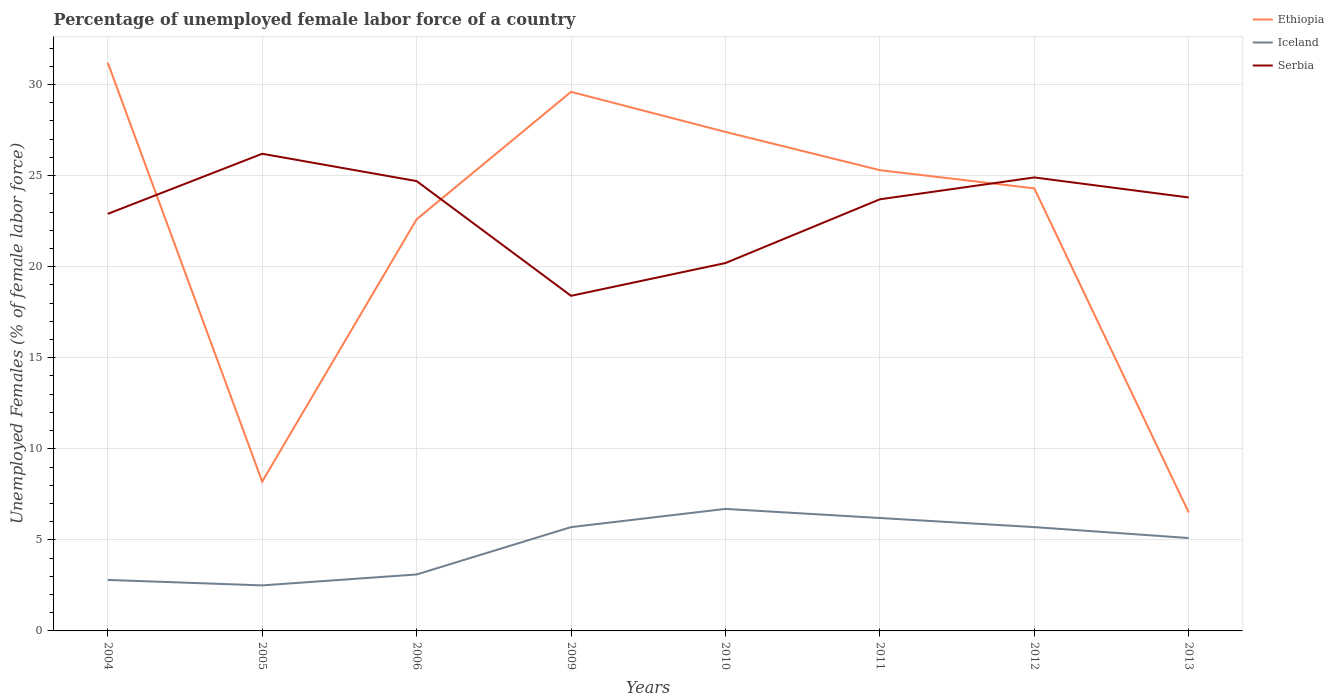Is the number of lines equal to the number of legend labels?
Provide a succinct answer. Yes. What is the total percentage of unemployed female labor force in Serbia in the graph?
Give a very brief answer. 6.3. What is the difference between the highest and the second highest percentage of unemployed female labor force in Iceland?
Provide a succinct answer. 4.2. What is the difference between the highest and the lowest percentage of unemployed female labor force in Iceland?
Your answer should be very brief. 5. Is the percentage of unemployed female labor force in Iceland strictly greater than the percentage of unemployed female labor force in Ethiopia over the years?
Make the answer very short. Yes. How many lines are there?
Your response must be concise. 3. How many years are there in the graph?
Provide a short and direct response. 8. Are the values on the major ticks of Y-axis written in scientific E-notation?
Keep it short and to the point. No. Does the graph contain grids?
Provide a succinct answer. Yes. Where does the legend appear in the graph?
Your response must be concise. Top right. How many legend labels are there?
Your answer should be compact. 3. How are the legend labels stacked?
Make the answer very short. Vertical. What is the title of the graph?
Your answer should be compact. Percentage of unemployed female labor force of a country. Does "American Samoa" appear as one of the legend labels in the graph?
Your answer should be very brief. No. What is the label or title of the Y-axis?
Keep it short and to the point. Unemployed Females (% of female labor force). What is the Unemployed Females (% of female labor force) of Ethiopia in 2004?
Make the answer very short. 31.2. What is the Unemployed Females (% of female labor force) in Iceland in 2004?
Give a very brief answer. 2.8. What is the Unemployed Females (% of female labor force) of Serbia in 2004?
Provide a succinct answer. 22.9. What is the Unemployed Females (% of female labor force) of Ethiopia in 2005?
Give a very brief answer. 8.2. What is the Unemployed Females (% of female labor force) of Serbia in 2005?
Make the answer very short. 26.2. What is the Unemployed Females (% of female labor force) of Ethiopia in 2006?
Provide a short and direct response. 22.6. What is the Unemployed Females (% of female labor force) of Iceland in 2006?
Offer a terse response. 3.1. What is the Unemployed Females (% of female labor force) in Serbia in 2006?
Ensure brevity in your answer.  24.7. What is the Unemployed Females (% of female labor force) of Ethiopia in 2009?
Provide a succinct answer. 29.6. What is the Unemployed Females (% of female labor force) of Iceland in 2009?
Provide a short and direct response. 5.7. What is the Unemployed Females (% of female labor force) of Serbia in 2009?
Offer a very short reply. 18.4. What is the Unemployed Females (% of female labor force) in Ethiopia in 2010?
Ensure brevity in your answer.  27.4. What is the Unemployed Females (% of female labor force) of Iceland in 2010?
Make the answer very short. 6.7. What is the Unemployed Females (% of female labor force) of Serbia in 2010?
Provide a short and direct response. 20.2. What is the Unemployed Females (% of female labor force) in Ethiopia in 2011?
Make the answer very short. 25.3. What is the Unemployed Females (% of female labor force) in Iceland in 2011?
Your response must be concise. 6.2. What is the Unemployed Females (% of female labor force) of Serbia in 2011?
Offer a terse response. 23.7. What is the Unemployed Females (% of female labor force) of Ethiopia in 2012?
Keep it short and to the point. 24.3. What is the Unemployed Females (% of female labor force) in Iceland in 2012?
Provide a short and direct response. 5.7. What is the Unemployed Females (% of female labor force) in Serbia in 2012?
Ensure brevity in your answer.  24.9. What is the Unemployed Females (% of female labor force) in Ethiopia in 2013?
Provide a short and direct response. 6.5. What is the Unemployed Females (% of female labor force) in Iceland in 2013?
Provide a short and direct response. 5.1. What is the Unemployed Females (% of female labor force) of Serbia in 2013?
Make the answer very short. 23.8. Across all years, what is the maximum Unemployed Females (% of female labor force) in Ethiopia?
Keep it short and to the point. 31.2. Across all years, what is the maximum Unemployed Females (% of female labor force) of Iceland?
Give a very brief answer. 6.7. Across all years, what is the maximum Unemployed Females (% of female labor force) of Serbia?
Provide a succinct answer. 26.2. Across all years, what is the minimum Unemployed Females (% of female labor force) of Ethiopia?
Provide a short and direct response. 6.5. Across all years, what is the minimum Unemployed Females (% of female labor force) in Iceland?
Your response must be concise. 2.5. Across all years, what is the minimum Unemployed Females (% of female labor force) in Serbia?
Offer a terse response. 18.4. What is the total Unemployed Females (% of female labor force) in Ethiopia in the graph?
Your answer should be very brief. 175.1. What is the total Unemployed Females (% of female labor force) in Iceland in the graph?
Your answer should be compact. 37.8. What is the total Unemployed Females (% of female labor force) of Serbia in the graph?
Keep it short and to the point. 184.8. What is the difference between the Unemployed Females (% of female labor force) of Ethiopia in 2004 and that in 2005?
Your answer should be very brief. 23. What is the difference between the Unemployed Females (% of female labor force) of Iceland in 2004 and that in 2005?
Your response must be concise. 0.3. What is the difference between the Unemployed Females (% of female labor force) of Serbia in 2004 and that in 2005?
Your answer should be compact. -3.3. What is the difference between the Unemployed Females (% of female labor force) in Ethiopia in 2004 and that in 2006?
Provide a short and direct response. 8.6. What is the difference between the Unemployed Females (% of female labor force) in Iceland in 2004 and that in 2009?
Your response must be concise. -2.9. What is the difference between the Unemployed Females (% of female labor force) of Serbia in 2004 and that in 2010?
Your answer should be compact. 2.7. What is the difference between the Unemployed Females (% of female labor force) of Iceland in 2004 and that in 2011?
Provide a succinct answer. -3.4. What is the difference between the Unemployed Females (% of female labor force) in Ethiopia in 2004 and that in 2012?
Make the answer very short. 6.9. What is the difference between the Unemployed Females (% of female labor force) of Iceland in 2004 and that in 2012?
Ensure brevity in your answer.  -2.9. What is the difference between the Unemployed Females (% of female labor force) of Ethiopia in 2004 and that in 2013?
Provide a succinct answer. 24.7. What is the difference between the Unemployed Females (% of female labor force) in Iceland in 2004 and that in 2013?
Your response must be concise. -2.3. What is the difference between the Unemployed Females (% of female labor force) in Serbia in 2004 and that in 2013?
Keep it short and to the point. -0.9. What is the difference between the Unemployed Females (% of female labor force) of Ethiopia in 2005 and that in 2006?
Keep it short and to the point. -14.4. What is the difference between the Unemployed Females (% of female labor force) in Serbia in 2005 and that in 2006?
Offer a very short reply. 1.5. What is the difference between the Unemployed Females (% of female labor force) in Ethiopia in 2005 and that in 2009?
Your answer should be very brief. -21.4. What is the difference between the Unemployed Females (% of female labor force) in Ethiopia in 2005 and that in 2010?
Your response must be concise. -19.2. What is the difference between the Unemployed Females (% of female labor force) in Iceland in 2005 and that in 2010?
Provide a succinct answer. -4.2. What is the difference between the Unemployed Females (% of female labor force) of Ethiopia in 2005 and that in 2011?
Keep it short and to the point. -17.1. What is the difference between the Unemployed Females (% of female labor force) of Serbia in 2005 and that in 2011?
Provide a short and direct response. 2.5. What is the difference between the Unemployed Females (% of female labor force) in Ethiopia in 2005 and that in 2012?
Offer a terse response. -16.1. What is the difference between the Unemployed Females (% of female labor force) in Iceland in 2005 and that in 2012?
Offer a very short reply. -3.2. What is the difference between the Unemployed Females (% of female labor force) in Ethiopia in 2005 and that in 2013?
Offer a very short reply. 1.7. What is the difference between the Unemployed Females (% of female labor force) in Iceland in 2005 and that in 2013?
Offer a terse response. -2.6. What is the difference between the Unemployed Females (% of female labor force) of Iceland in 2006 and that in 2009?
Provide a succinct answer. -2.6. What is the difference between the Unemployed Females (% of female labor force) of Serbia in 2006 and that in 2010?
Give a very brief answer. 4.5. What is the difference between the Unemployed Females (% of female labor force) of Serbia in 2006 and that in 2011?
Give a very brief answer. 1. What is the difference between the Unemployed Females (% of female labor force) of Ethiopia in 2006 and that in 2012?
Give a very brief answer. -1.7. What is the difference between the Unemployed Females (% of female labor force) in Iceland in 2006 and that in 2012?
Make the answer very short. -2.6. What is the difference between the Unemployed Females (% of female labor force) in Serbia in 2006 and that in 2012?
Keep it short and to the point. -0.2. What is the difference between the Unemployed Females (% of female labor force) in Ethiopia in 2006 and that in 2013?
Offer a terse response. 16.1. What is the difference between the Unemployed Females (% of female labor force) of Iceland in 2006 and that in 2013?
Offer a terse response. -2. What is the difference between the Unemployed Females (% of female labor force) in Serbia in 2006 and that in 2013?
Your response must be concise. 0.9. What is the difference between the Unemployed Females (% of female labor force) in Ethiopia in 2009 and that in 2010?
Your answer should be very brief. 2.2. What is the difference between the Unemployed Females (% of female labor force) of Iceland in 2009 and that in 2010?
Your answer should be very brief. -1. What is the difference between the Unemployed Females (% of female labor force) in Iceland in 2009 and that in 2012?
Provide a succinct answer. 0. What is the difference between the Unemployed Females (% of female labor force) of Serbia in 2009 and that in 2012?
Give a very brief answer. -6.5. What is the difference between the Unemployed Females (% of female labor force) in Ethiopia in 2009 and that in 2013?
Ensure brevity in your answer.  23.1. What is the difference between the Unemployed Females (% of female labor force) in Iceland in 2009 and that in 2013?
Offer a terse response. 0.6. What is the difference between the Unemployed Females (% of female labor force) in Serbia in 2009 and that in 2013?
Your answer should be very brief. -5.4. What is the difference between the Unemployed Females (% of female labor force) in Iceland in 2010 and that in 2011?
Provide a succinct answer. 0.5. What is the difference between the Unemployed Females (% of female labor force) of Serbia in 2010 and that in 2011?
Provide a succinct answer. -3.5. What is the difference between the Unemployed Females (% of female labor force) of Serbia in 2010 and that in 2012?
Your answer should be compact. -4.7. What is the difference between the Unemployed Females (% of female labor force) of Ethiopia in 2010 and that in 2013?
Provide a short and direct response. 20.9. What is the difference between the Unemployed Females (% of female labor force) of Serbia in 2010 and that in 2013?
Make the answer very short. -3.6. What is the difference between the Unemployed Females (% of female labor force) in Ethiopia in 2011 and that in 2012?
Keep it short and to the point. 1. What is the difference between the Unemployed Females (% of female labor force) in Iceland in 2011 and that in 2012?
Provide a short and direct response. 0.5. What is the difference between the Unemployed Females (% of female labor force) of Serbia in 2011 and that in 2012?
Your answer should be very brief. -1.2. What is the difference between the Unemployed Females (% of female labor force) in Ethiopia in 2011 and that in 2013?
Offer a very short reply. 18.8. What is the difference between the Unemployed Females (% of female labor force) in Serbia in 2011 and that in 2013?
Offer a very short reply. -0.1. What is the difference between the Unemployed Females (% of female labor force) of Ethiopia in 2012 and that in 2013?
Offer a terse response. 17.8. What is the difference between the Unemployed Females (% of female labor force) in Ethiopia in 2004 and the Unemployed Females (% of female labor force) in Iceland in 2005?
Your answer should be very brief. 28.7. What is the difference between the Unemployed Females (% of female labor force) of Iceland in 2004 and the Unemployed Females (% of female labor force) of Serbia in 2005?
Offer a terse response. -23.4. What is the difference between the Unemployed Females (% of female labor force) of Ethiopia in 2004 and the Unemployed Females (% of female labor force) of Iceland in 2006?
Your answer should be compact. 28.1. What is the difference between the Unemployed Females (% of female labor force) of Iceland in 2004 and the Unemployed Females (% of female labor force) of Serbia in 2006?
Make the answer very short. -21.9. What is the difference between the Unemployed Females (% of female labor force) of Ethiopia in 2004 and the Unemployed Females (% of female labor force) of Iceland in 2009?
Offer a terse response. 25.5. What is the difference between the Unemployed Females (% of female labor force) of Iceland in 2004 and the Unemployed Females (% of female labor force) of Serbia in 2009?
Offer a very short reply. -15.6. What is the difference between the Unemployed Females (% of female labor force) of Ethiopia in 2004 and the Unemployed Females (% of female labor force) of Iceland in 2010?
Provide a short and direct response. 24.5. What is the difference between the Unemployed Females (% of female labor force) of Iceland in 2004 and the Unemployed Females (% of female labor force) of Serbia in 2010?
Provide a short and direct response. -17.4. What is the difference between the Unemployed Females (% of female labor force) in Iceland in 2004 and the Unemployed Females (% of female labor force) in Serbia in 2011?
Offer a terse response. -20.9. What is the difference between the Unemployed Females (% of female labor force) of Ethiopia in 2004 and the Unemployed Females (% of female labor force) of Serbia in 2012?
Ensure brevity in your answer.  6.3. What is the difference between the Unemployed Females (% of female labor force) in Iceland in 2004 and the Unemployed Females (% of female labor force) in Serbia in 2012?
Your response must be concise. -22.1. What is the difference between the Unemployed Females (% of female labor force) of Ethiopia in 2004 and the Unemployed Females (% of female labor force) of Iceland in 2013?
Provide a short and direct response. 26.1. What is the difference between the Unemployed Females (% of female labor force) of Ethiopia in 2004 and the Unemployed Females (% of female labor force) of Serbia in 2013?
Offer a very short reply. 7.4. What is the difference between the Unemployed Females (% of female labor force) of Ethiopia in 2005 and the Unemployed Females (% of female labor force) of Serbia in 2006?
Give a very brief answer. -16.5. What is the difference between the Unemployed Females (% of female labor force) of Iceland in 2005 and the Unemployed Females (% of female labor force) of Serbia in 2006?
Provide a succinct answer. -22.2. What is the difference between the Unemployed Females (% of female labor force) in Ethiopia in 2005 and the Unemployed Females (% of female labor force) in Serbia in 2009?
Your answer should be very brief. -10.2. What is the difference between the Unemployed Females (% of female labor force) of Iceland in 2005 and the Unemployed Females (% of female labor force) of Serbia in 2009?
Provide a short and direct response. -15.9. What is the difference between the Unemployed Females (% of female labor force) in Ethiopia in 2005 and the Unemployed Females (% of female labor force) in Iceland in 2010?
Give a very brief answer. 1.5. What is the difference between the Unemployed Females (% of female labor force) in Ethiopia in 2005 and the Unemployed Females (% of female labor force) in Serbia in 2010?
Provide a short and direct response. -12. What is the difference between the Unemployed Females (% of female labor force) in Iceland in 2005 and the Unemployed Females (% of female labor force) in Serbia in 2010?
Keep it short and to the point. -17.7. What is the difference between the Unemployed Females (% of female labor force) in Ethiopia in 2005 and the Unemployed Females (% of female labor force) in Iceland in 2011?
Offer a terse response. 2. What is the difference between the Unemployed Females (% of female labor force) of Ethiopia in 2005 and the Unemployed Females (% of female labor force) of Serbia in 2011?
Provide a succinct answer. -15.5. What is the difference between the Unemployed Females (% of female labor force) in Iceland in 2005 and the Unemployed Females (% of female labor force) in Serbia in 2011?
Make the answer very short. -21.2. What is the difference between the Unemployed Females (% of female labor force) of Ethiopia in 2005 and the Unemployed Females (% of female labor force) of Iceland in 2012?
Give a very brief answer. 2.5. What is the difference between the Unemployed Females (% of female labor force) in Ethiopia in 2005 and the Unemployed Females (% of female labor force) in Serbia in 2012?
Your response must be concise. -16.7. What is the difference between the Unemployed Females (% of female labor force) of Iceland in 2005 and the Unemployed Females (% of female labor force) of Serbia in 2012?
Offer a very short reply. -22.4. What is the difference between the Unemployed Females (% of female labor force) in Ethiopia in 2005 and the Unemployed Females (% of female labor force) in Serbia in 2013?
Provide a short and direct response. -15.6. What is the difference between the Unemployed Females (% of female labor force) in Iceland in 2005 and the Unemployed Females (% of female labor force) in Serbia in 2013?
Provide a succinct answer. -21.3. What is the difference between the Unemployed Females (% of female labor force) of Ethiopia in 2006 and the Unemployed Females (% of female labor force) of Serbia in 2009?
Your answer should be very brief. 4.2. What is the difference between the Unemployed Females (% of female labor force) of Iceland in 2006 and the Unemployed Females (% of female labor force) of Serbia in 2009?
Keep it short and to the point. -15.3. What is the difference between the Unemployed Females (% of female labor force) in Iceland in 2006 and the Unemployed Females (% of female labor force) in Serbia in 2010?
Offer a terse response. -17.1. What is the difference between the Unemployed Females (% of female labor force) in Ethiopia in 2006 and the Unemployed Females (% of female labor force) in Iceland in 2011?
Offer a terse response. 16.4. What is the difference between the Unemployed Females (% of female labor force) of Iceland in 2006 and the Unemployed Females (% of female labor force) of Serbia in 2011?
Make the answer very short. -20.6. What is the difference between the Unemployed Females (% of female labor force) in Iceland in 2006 and the Unemployed Females (% of female labor force) in Serbia in 2012?
Ensure brevity in your answer.  -21.8. What is the difference between the Unemployed Females (% of female labor force) of Ethiopia in 2006 and the Unemployed Females (% of female labor force) of Serbia in 2013?
Provide a short and direct response. -1.2. What is the difference between the Unemployed Females (% of female labor force) of Iceland in 2006 and the Unemployed Females (% of female labor force) of Serbia in 2013?
Provide a short and direct response. -20.7. What is the difference between the Unemployed Females (% of female labor force) of Ethiopia in 2009 and the Unemployed Females (% of female labor force) of Iceland in 2010?
Keep it short and to the point. 22.9. What is the difference between the Unemployed Females (% of female labor force) of Ethiopia in 2009 and the Unemployed Females (% of female labor force) of Iceland in 2011?
Provide a short and direct response. 23.4. What is the difference between the Unemployed Females (% of female labor force) of Iceland in 2009 and the Unemployed Females (% of female labor force) of Serbia in 2011?
Offer a terse response. -18. What is the difference between the Unemployed Females (% of female labor force) of Ethiopia in 2009 and the Unemployed Females (% of female labor force) of Iceland in 2012?
Provide a succinct answer. 23.9. What is the difference between the Unemployed Females (% of female labor force) of Ethiopia in 2009 and the Unemployed Females (% of female labor force) of Serbia in 2012?
Give a very brief answer. 4.7. What is the difference between the Unemployed Females (% of female labor force) in Iceland in 2009 and the Unemployed Females (% of female labor force) in Serbia in 2012?
Your answer should be compact. -19.2. What is the difference between the Unemployed Females (% of female labor force) of Ethiopia in 2009 and the Unemployed Females (% of female labor force) of Iceland in 2013?
Offer a very short reply. 24.5. What is the difference between the Unemployed Females (% of female labor force) of Ethiopia in 2009 and the Unemployed Females (% of female labor force) of Serbia in 2013?
Give a very brief answer. 5.8. What is the difference between the Unemployed Females (% of female labor force) of Iceland in 2009 and the Unemployed Females (% of female labor force) of Serbia in 2013?
Keep it short and to the point. -18.1. What is the difference between the Unemployed Females (% of female labor force) of Ethiopia in 2010 and the Unemployed Females (% of female labor force) of Iceland in 2011?
Your response must be concise. 21.2. What is the difference between the Unemployed Females (% of female labor force) of Ethiopia in 2010 and the Unemployed Females (% of female labor force) of Iceland in 2012?
Give a very brief answer. 21.7. What is the difference between the Unemployed Females (% of female labor force) of Iceland in 2010 and the Unemployed Females (% of female labor force) of Serbia in 2012?
Make the answer very short. -18.2. What is the difference between the Unemployed Females (% of female labor force) of Ethiopia in 2010 and the Unemployed Females (% of female labor force) of Iceland in 2013?
Offer a very short reply. 22.3. What is the difference between the Unemployed Females (% of female labor force) of Ethiopia in 2010 and the Unemployed Females (% of female labor force) of Serbia in 2013?
Your response must be concise. 3.6. What is the difference between the Unemployed Females (% of female labor force) in Iceland in 2010 and the Unemployed Females (% of female labor force) in Serbia in 2013?
Provide a succinct answer. -17.1. What is the difference between the Unemployed Females (% of female labor force) of Ethiopia in 2011 and the Unemployed Females (% of female labor force) of Iceland in 2012?
Your answer should be compact. 19.6. What is the difference between the Unemployed Females (% of female labor force) in Ethiopia in 2011 and the Unemployed Females (% of female labor force) in Serbia in 2012?
Give a very brief answer. 0.4. What is the difference between the Unemployed Females (% of female labor force) in Iceland in 2011 and the Unemployed Females (% of female labor force) in Serbia in 2012?
Your response must be concise. -18.7. What is the difference between the Unemployed Females (% of female labor force) in Ethiopia in 2011 and the Unemployed Females (% of female labor force) in Iceland in 2013?
Make the answer very short. 20.2. What is the difference between the Unemployed Females (% of female labor force) of Iceland in 2011 and the Unemployed Females (% of female labor force) of Serbia in 2013?
Make the answer very short. -17.6. What is the difference between the Unemployed Females (% of female labor force) in Ethiopia in 2012 and the Unemployed Females (% of female labor force) in Iceland in 2013?
Your answer should be very brief. 19.2. What is the difference between the Unemployed Females (% of female labor force) in Iceland in 2012 and the Unemployed Females (% of female labor force) in Serbia in 2013?
Provide a short and direct response. -18.1. What is the average Unemployed Females (% of female labor force) of Ethiopia per year?
Your response must be concise. 21.89. What is the average Unemployed Females (% of female labor force) of Iceland per year?
Keep it short and to the point. 4.72. What is the average Unemployed Females (% of female labor force) in Serbia per year?
Your response must be concise. 23.1. In the year 2004, what is the difference between the Unemployed Females (% of female labor force) in Ethiopia and Unemployed Females (% of female labor force) in Iceland?
Provide a short and direct response. 28.4. In the year 2004, what is the difference between the Unemployed Females (% of female labor force) of Iceland and Unemployed Females (% of female labor force) of Serbia?
Provide a short and direct response. -20.1. In the year 2005, what is the difference between the Unemployed Females (% of female labor force) in Ethiopia and Unemployed Females (% of female labor force) in Serbia?
Offer a very short reply. -18. In the year 2005, what is the difference between the Unemployed Females (% of female labor force) in Iceland and Unemployed Females (% of female labor force) in Serbia?
Provide a succinct answer. -23.7. In the year 2006, what is the difference between the Unemployed Females (% of female labor force) in Ethiopia and Unemployed Females (% of female labor force) in Serbia?
Provide a succinct answer. -2.1. In the year 2006, what is the difference between the Unemployed Females (% of female labor force) in Iceland and Unemployed Females (% of female labor force) in Serbia?
Your answer should be compact. -21.6. In the year 2009, what is the difference between the Unemployed Females (% of female labor force) of Ethiopia and Unemployed Females (% of female labor force) of Iceland?
Keep it short and to the point. 23.9. In the year 2009, what is the difference between the Unemployed Females (% of female labor force) of Ethiopia and Unemployed Females (% of female labor force) of Serbia?
Your response must be concise. 11.2. In the year 2009, what is the difference between the Unemployed Females (% of female labor force) in Iceland and Unemployed Females (% of female labor force) in Serbia?
Provide a succinct answer. -12.7. In the year 2010, what is the difference between the Unemployed Females (% of female labor force) of Ethiopia and Unemployed Females (% of female labor force) of Iceland?
Offer a terse response. 20.7. In the year 2010, what is the difference between the Unemployed Females (% of female labor force) of Ethiopia and Unemployed Females (% of female labor force) of Serbia?
Your answer should be very brief. 7.2. In the year 2010, what is the difference between the Unemployed Females (% of female labor force) of Iceland and Unemployed Females (% of female labor force) of Serbia?
Your answer should be very brief. -13.5. In the year 2011, what is the difference between the Unemployed Females (% of female labor force) in Ethiopia and Unemployed Females (% of female labor force) in Iceland?
Your answer should be compact. 19.1. In the year 2011, what is the difference between the Unemployed Females (% of female labor force) of Ethiopia and Unemployed Females (% of female labor force) of Serbia?
Provide a short and direct response. 1.6. In the year 2011, what is the difference between the Unemployed Females (% of female labor force) in Iceland and Unemployed Females (% of female labor force) in Serbia?
Provide a short and direct response. -17.5. In the year 2012, what is the difference between the Unemployed Females (% of female labor force) of Ethiopia and Unemployed Females (% of female labor force) of Serbia?
Your answer should be very brief. -0.6. In the year 2012, what is the difference between the Unemployed Females (% of female labor force) of Iceland and Unemployed Females (% of female labor force) of Serbia?
Provide a short and direct response. -19.2. In the year 2013, what is the difference between the Unemployed Females (% of female labor force) of Ethiopia and Unemployed Females (% of female labor force) of Serbia?
Ensure brevity in your answer.  -17.3. In the year 2013, what is the difference between the Unemployed Females (% of female labor force) of Iceland and Unemployed Females (% of female labor force) of Serbia?
Offer a terse response. -18.7. What is the ratio of the Unemployed Females (% of female labor force) in Ethiopia in 2004 to that in 2005?
Offer a terse response. 3.8. What is the ratio of the Unemployed Females (% of female labor force) of Iceland in 2004 to that in 2005?
Provide a short and direct response. 1.12. What is the ratio of the Unemployed Females (% of female labor force) in Serbia in 2004 to that in 2005?
Your answer should be compact. 0.87. What is the ratio of the Unemployed Females (% of female labor force) of Ethiopia in 2004 to that in 2006?
Provide a short and direct response. 1.38. What is the ratio of the Unemployed Females (% of female labor force) of Iceland in 2004 to that in 2006?
Provide a short and direct response. 0.9. What is the ratio of the Unemployed Females (% of female labor force) of Serbia in 2004 to that in 2006?
Your response must be concise. 0.93. What is the ratio of the Unemployed Females (% of female labor force) of Ethiopia in 2004 to that in 2009?
Keep it short and to the point. 1.05. What is the ratio of the Unemployed Females (% of female labor force) in Iceland in 2004 to that in 2009?
Provide a succinct answer. 0.49. What is the ratio of the Unemployed Females (% of female labor force) of Serbia in 2004 to that in 2009?
Give a very brief answer. 1.24. What is the ratio of the Unemployed Females (% of female labor force) in Ethiopia in 2004 to that in 2010?
Keep it short and to the point. 1.14. What is the ratio of the Unemployed Females (% of female labor force) of Iceland in 2004 to that in 2010?
Give a very brief answer. 0.42. What is the ratio of the Unemployed Females (% of female labor force) in Serbia in 2004 to that in 2010?
Your answer should be compact. 1.13. What is the ratio of the Unemployed Females (% of female labor force) in Ethiopia in 2004 to that in 2011?
Provide a short and direct response. 1.23. What is the ratio of the Unemployed Females (% of female labor force) in Iceland in 2004 to that in 2011?
Provide a succinct answer. 0.45. What is the ratio of the Unemployed Females (% of female labor force) of Serbia in 2004 to that in 2011?
Ensure brevity in your answer.  0.97. What is the ratio of the Unemployed Females (% of female labor force) of Ethiopia in 2004 to that in 2012?
Provide a succinct answer. 1.28. What is the ratio of the Unemployed Females (% of female labor force) in Iceland in 2004 to that in 2012?
Provide a succinct answer. 0.49. What is the ratio of the Unemployed Females (% of female labor force) in Serbia in 2004 to that in 2012?
Your answer should be compact. 0.92. What is the ratio of the Unemployed Females (% of female labor force) in Iceland in 2004 to that in 2013?
Offer a very short reply. 0.55. What is the ratio of the Unemployed Females (% of female labor force) in Serbia in 2004 to that in 2013?
Keep it short and to the point. 0.96. What is the ratio of the Unemployed Females (% of female labor force) of Ethiopia in 2005 to that in 2006?
Provide a succinct answer. 0.36. What is the ratio of the Unemployed Females (% of female labor force) in Iceland in 2005 to that in 2006?
Your response must be concise. 0.81. What is the ratio of the Unemployed Females (% of female labor force) of Serbia in 2005 to that in 2006?
Provide a short and direct response. 1.06. What is the ratio of the Unemployed Females (% of female labor force) in Ethiopia in 2005 to that in 2009?
Your answer should be very brief. 0.28. What is the ratio of the Unemployed Females (% of female labor force) in Iceland in 2005 to that in 2009?
Provide a succinct answer. 0.44. What is the ratio of the Unemployed Females (% of female labor force) of Serbia in 2005 to that in 2009?
Make the answer very short. 1.42. What is the ratio of the Unemployed Females (% of female labor force) in Ethiopia in 2005 to that in 2010?
Ensure brevity in your answer.  0.3. What is the ratio of the Unemployed Females (% of female labor force) of Iceland in 2005 to that in 2010?
Give a very brief answer. 0.37. What is the ratio of the Unemployed Females (% of female labor force) of Serbia in 2005 to that in 2010?
Ensure brevity in your answer.  1.3. What is the ratio of the Unemployed Females (% of female labor force) in Ethiopia in 2005 to that in 2011?
Offer a very short reply. 0.32. What is the ratio of the Unemployed Females (% of female labor force) in Iceland in 2005 to that in 2011?
Make the answer very short. 0.4. What is the ratio of the Unemployed Females (% of female labor force) in Serbia in 2005 to that in 2011?
Offer a terse response. 1.11. What is the ratio of the Unemployed Females (% of female labor force) of Ethiopia in 2005 to that in 2012?
Offer a terse response. 0.34. What is the ratio of the Unemployed Females (% of female labor force) of Iceland in 2005 to that in 2012?
Provide a succinct answer. 0.44. What is the ratio of the Unemployed Females (% of female labor force) of Serbia in 2005 to that in 2012?
Your response must be concise. 1.05. What is the ratio of the Unemployed Females (% of female labor force) in Ethiopia in 2005 to that in 2013?
Your answer should be very brief. 1.26. What is the ratio of the Unemployed Females (% of female labor force) of Iceland in 2005 to that in 2013?
Provide a succinct answer. 0.49. What is the ratio of the Unemployed Females (% of female labor force) in Serbia in 2005 to that in 2013?
Make the answer very short. 1.1. What is the ratio of the Unemployed Females (% of female labor force) of Ethiopia in 2006 to that in 2009?
Offer a very short reply. 0.76. What is the ratio of the Unemployed Females (% of female labor force) in Iceland in 2006 to that in 2009?
Keep it short and to the point. 0.54. What is the ratio of the Unemployed Females (% of female labor force) in Serbia in 2006 to that in 2009?
Provide a succinct answer. 1.34. What is the ratio of the Unemployed Females (% of female labor force) in Ethiopia in 2006 to that in 2010?
Offer a very short reply. 0.82. What is the ratio of the Unemployed Females (% of female labor force) of Iceland in 2006 to that in 2010?
Offer a terse response. 0.46. What is the ratio of the Unemployed Females (% of female labor force) of Serbia in 2006 to that in 2010?
Your answer should be compact. 1.22. What is the ratio of the Unemployed Females (% of female labor force) in Ethiopia in 2006 to that in 2011?
Provide a short and direct response. 0.89. What is the ratio of the Unemployed Females (% of female labor force) of Serbia in 2006 to that in 2011?
Your answer should be compact. 1.04. What is the ratio of the Unemployed Females (% of female labor force) of Ethiopia in 2006 to that in 2012?
Provide a succinct answer. 0.93. What is the ratio of the Unemployed Females (% of female labor force) of Iceland in 2006 to that in 2012?
Make the answer very short. 0.54. What is the ratio of the Unemployed Females (% of female labor force) of Serbia in 2006 to that in 2012?
Offer a terse response. 0.99. What is the ratio of the Unemployed Females (% of female labor force) in Ethiopia in 2006 to that in 2013?
Give a very brief answer. 3.48. What is the ratio of the Unemployed Females (% of female labor force) in Iceland in 2006 to that in 2013?
Provide a succinct answer. 0.61. What is the ratio of the Unemployed Females (% of female labor force) of Serbia in 2006 to that in 2013?
Give a very brief answer. 1.04. What is the ratio of the Unemployed Females (% of female labor force) of Ethiopia in 2009 to that in 2010?
Give a very brief answer. 1.08. What is the ratio of the Unemployed Females (% of female labor force) of Iceland in 2009 to that in 2010?
Offer a very short reply. 0.85. What is the ratio of the Unemployed Females (% of female labor force) of Serbia in 2009 to that in 2010?
Your response must be concise. 0.91. What is the ratio of the Unemployed Females (% of female labor force) in Ethiopia in 2009 to that in 2011?
Offer a terse response. 1.17. What is the ratio of the Unemployed Females (% of female labor force) of Iceland in 2009 to that in 2011?
Provide a short and direct response. 0.92. What is the ratio of the Unemployed Females (% of female labor force) of Serbia in 2009 to that in 2011?
Offer a terse response. 0.78. What is the ratio of the Unemployed Females (% of female labor force) of Ethiopia in 2009 to that in 2012?
Make the answer very short. 1.22. What is the ratio of the Unemployed Females (% of female labor force) in Serbia in 2009 to that in 2012?
Your response must be concise. 0.74. What is the ratio of the Unemployed Females (% of female labor force) in Ethiopia in 2009 to that in 2013?
Ensure brevity in your answer.  4.55. What is the ratio of the Unemployed Females (% of female labor force) of Iceland in 2009 to that in 2013?
Offer a terse response. 1.12. What is the ratio of the Unemployed Females (% of female labor force) in Serbia in 2009 to that in 2013?
Keep it short and to the point. 0.77. What is the ratio of the Unemployed Females (% of female labor force) of Ethiopia in 2010 to that in 2011?
Your response must be concise. 1.08. What is the ratio of the Unemployed Females (% of female labor force) in Iceland in 2010 to that in 2011?
Your response must be concise. 1.08. What is the ratio of the Unemployed Females (% of female labor force) in Serbia in 2010 to that in 2011?
Provide a succinct answer. 0.85. What is the ratio of the Unemployed Females (% of female labor force) in Ethiopia in 2010 to that in 2012?
Keep it short and to the point. 1.13. What is the ratio of the Unemployed Females (% of female labor force) of Iceland in 2010 to that in 2012?
Provide a short and direct response. 1.18. What is the ratio of the Unemployed Females (% of female labor force) in Serbia in 2010 to that in 2012?
Keep it short and to the point. 0.81. What is the ratio of the Unemployed Females (% of female labor force) in Ethiopia in 2010 to that in 2013?
Your response must be concise. 4.22. What is the ratio of the Unemployed Females (% of female labor force) of Iceland in 2010 to that in 2013?
Provide a short and direct response. 1.31. What is the ratio of the Unemployed Females (% of female labor force) of Serbia in 2010 to that in 2013?
Your response must be concise. 0.85. What is the ratio of the Unemployed Females (% of female labor force) in Ethiopia in 2011 to that in 2012?
Make the answer very short. 1.04. What is the ratio of the Unemployed Females (% of female labor force) of Iceland in 2011 to that in 2012?
Keep it short and to the point. 1.09. What is the ratio of the Unemployed Females (% of female labor force) of Serbia in 2011 to that in 2012?
Keep it short and to the point. 0.95. What is the ratio of the Unemployed Females (% of female labor force) of Ethiopia in 2011 to that in 2013?
Provide a succinct answer. 3.89. What is the ratio of the Unemployed Females (% of female labor force) in Iceland in 2011 to that in 2013?
Offer a terse response. 1.22. What is the ratio of the Unemployed Females (% of female labor force) of Ethiopia in 2012 to that in 2013?
Provide a succinct answer. 3.74. What is the ratio of the Unemployed Females (% of female labor force) of Iceland in 2012 to that in 2013?
Your response must be concise. 1.12. What is the ratio of the Unemployed Females (% of female labor force) in Serbia in 2012 to that in 2013?
Provide a short and direct response. 1.05. What is the difference between the highest and the second highest Unemployed Females (% of female labor force) of Ethiopia?
Provide a succinct answer. 1.6. What is the difference between the highest and the second highest Unemployed Females (% of female labor force) in Iceland?
Make the answer very short. 0.5. What is the difference between the highest and the second highest Unemployed Females (% of female labor force) in Serbia?
Offer a very short reply. 1.3. What is the difference between the highest and the lowest Unemployed Females (% of female labor force) in Ethiopia?
Make the answer very short. 24.7. What is the difference between the highest and the lowest Unemployed Females (% of female labor force) in Iceland?
Provide a succinct answer. 4.2. What is the difference between the highest and the lowest Unemployed Females (% of female labor force) in Serbia?
Provide a succinct answer. 7.8. 